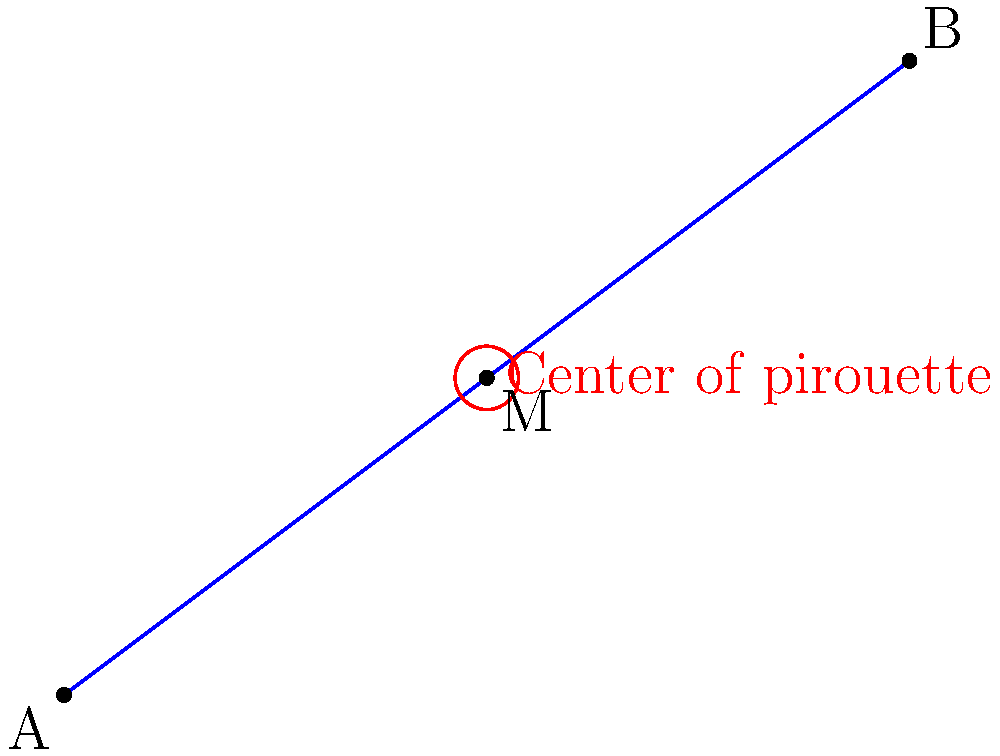A ballet dancer performs a pirouette starting at point A(-3, 1) and ending at point B(5, 7). To maintain perfect balance, the dancer needs to find the center point of this movement. Calculate the coordinates of point M, which represents the midpoint of line segment AB and the ideal center for the pirouette. To find the midpoint M of line segment AB, we can use the midpoint formula:

$$M = (\frac{x_1 + x_2}{2}, \frac{y_1 + y_2}{2})$$

Where $(x_1, y_1)$ are the coordinates of point A, and $(x_2, y_2)$ are the coordinates of point B.

Step 1: Identify the coordinates
A(-3, 1) and B(5, 7)

Step 2: Apply the midpoint formula
x-coordinate of M: $\frac{x_1 + x_2}{2} = \frac{-3 + 5}{2} = \frac{2}{2} = 1$
y-coordinate of M: $\frac{y_1 + y_2}{2} = \frac{1 + 7}{2} = \frac{8}{2} = 4$

Step 3: Combine the results
The midpoint M has coordinates (1, 4).

This point represents the center of the pirouette, where the dancer should focus to maintain balance throughout the movement.
Answer: M(1, 4) 